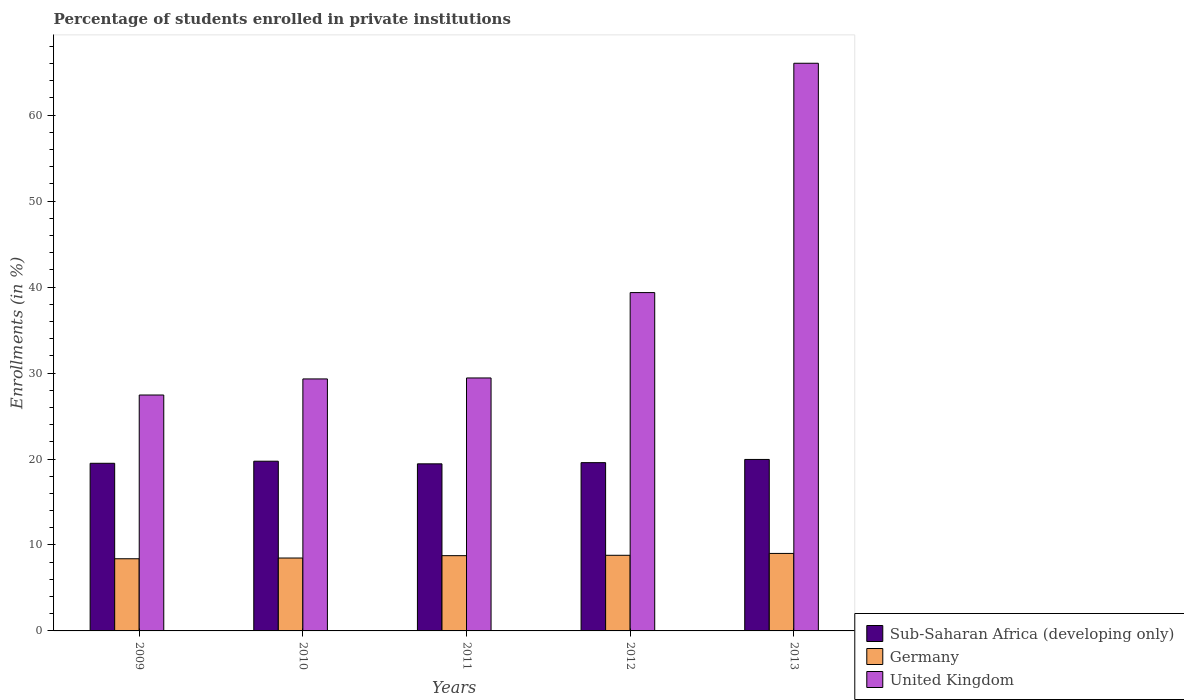Are the number of bars per tick equal to the number of legend labels?
Offer a very short reply. Yes. What is the label of the 5th group of bars from the left?
Provide a short and direct response. 2013. What is the percentage of trained teachers in Germany in 2009?
Offer a terse response. 8.4. Across all years, what is the maximum percentage of trained teachers in Germany?
Provide a short and direct response. 9.02. Across all years, what is the minimum percentage of trained teachers in Germany?
Give a very brief answer. 8.4. In which year was the percentage of trained teachers in United Kingdom minimum?
Offer a terse response. 2009. What is the total percentage of trained teachers in Germany in the graph?
Offer a very short reply. 43.45. What is the difference between the percentage of trained teachers in Germany in 2012 and that in 2013?
Give a very brief answer. -0.22. What is the difference between the percentage of trained teachers in Sub-Saharan Africa (developing only) in 2011 and the percentage of trained teachers in Germany in 2012?
Your response must be concise. 10.64. What is the average percentage of trained teachers in United Kingdom per year?
Your answer should be very brief. 38.32. In the year 2011, what is the difference between the percentage of trained teachers in Sub-Saharan Africa (developing only) and percentage of trained teachers in United Kingdom?
Make the answer very short. -9.99. What is the ratio of the percentage of trained teachers in Germany in 2010 to that in 2013?
Provide a succinct answer. 0.94. Is the difference between the percentage of trained teachers in Sub-Saharan Africa (developing only) in 2011 and 2013 greater than the difference between the percentage of trained teachers in United Kingdom in 2011 and 2013?
Provide a short and direct response. Yes. What is the difference between the highest and the second highest percentage of trained teachers in United Kingdom?
Your answer should be compact. 26.68. What is the difference between the highest and the lowest percentage of trained teachers in United Kingdom?
Your answer should be compact. 38.59. In how many years, is the percentage of trained teachers in Sub-Saharan Africa (developing only) greater than the average percentage of trained teachers in Sub-Saharan Africa (developing only) taken over all years?
Your answer should be very brief. 2. Is the sum of the percentage of trained teachers in United Kingdom in 2010 and 2012 greater than the maximum percentage of trained teachers in Germany across all years?
Make the answer very short. Yes. What does the 1st bar from the left in 2013 represents?
Give a very brief answer. Sub-Saharan Africa (developing only). What does the 3rd bar from the right in 2010 represents?
Keep it short and to the point. Sub-Saharan Africa (developing only). How many bars are there?
Offer a very short reply. 15. Are all the bars in the graph horizontal?
Offer a terse response. No. How many years are there in the graph?
Make the answer very short. 5. Are the values on the major ticks of Y-axis written in scientific E-notation?
Ensure brevity in your answer.  No. Does the graph contain any zero values?
Provide a succinct answer. No. Does the graph contain grids?
Your answer should be very brief. No. Where does the legend appear in the graph?
Keep it short and to the point. Bottom right. How many legend labels are there?
Make the answer very short. 3. What is the title of the graph?
Provide a short and direct response. Percentage of students enrolled in private institutions. Does "Korea (Republic)" appear as one of the legend labels in the graph?
Your response must be concise. No. What is the label or title of the Y-axis?
Provide a short and direct response. Enrollments (in %). What is the Enrollments (in %) in Sub-Saharan Africa (developing only) in 2009?
Your response must be concise. 19.5. What is the Enrollments (in %) of Germany in 2009?
Ensure brevity in your answer.  8.4. What is the Enrollments (in %) of United Kingdom in 2009?
Your response must be concise. 27.44. What is the Enrollments (in %) in Sub-Saharan Africa (developing only) in 2010?
Your response must be concise. 19.74. What is the Enrollments (in %) of Germany in 2010?
Your response must be concise. 8.48. What is the Enrollments (in %) of United Kingdom in 2010?
Make the answer very short. 29.32. What is the Enrollments (in %) in Sub-Saharan Africa (developing only) in 2011?
Give a very brief answer. 19.44. What is the Enrollments (in %) of Germany in 2011?
Keep it short and to the point. 8.76. What is the Enrollments (in %) of United Kingdom in 2011?
Make the answer very short. 29.43. What is the Enrollments (in %) of Sub-Saharan Africa (developing only) in 2012?
Your answer should be very brief. 19.58. What is the Enrollments (in %) in Germany in 2012?
Ensure brevity in your answer.  8.8. What is the Enrollments (in %) in United Kingdom in 2012?
Your response must be concise. 39.36. What is the Enrollments (in %) of Sub-Saharan Africa (developing only) in 2013?
Keep it short and to the point. 19.95. What is the Enrollments (in %) in Germany in 2013?
Provide a succinct answer. 9.02. What is the Enrollments (in %) in United Kingdom in 2013?
Your answer should be compact. 66.04. Across all years, what is the maximum Enrollments (in %) of Sub-Saharan Africa (developing only)?
Offer a very short reply. 19.95. Across all years, what is the maximum Enrollments (in %) of Germany?
Your response must be concise. 9.02. Across all years, what is the maximum Enrollments (in %) of United Kingdom?
Make the answer very short. 66.04. Across all years, what is the minimum Enrollments (in %) of Sub-Saharan Africa (developing only)?
Provide a succinct answer. 19.44. Across all years, what is the minimum Enrollments (in %) of Germany?
Your answer should be compact. 8.4. Across all years, what is the minimum Enrollments (in %) of United Kingdom?
Your answer should be compact. 27.44. What is the total Enrollments (in %) of Sub-Saharan Africa (developing only) in the graph?
Make the answer very short. 98.21. What is the total Enrollments (in %) of Germany in the graph?
Make the answer very short. 43.45. What is the total Enrollments (in %) of United Kingdom in the graph?
Make the answer very short. 191.59. What is the difference between the Enrollments (in %) of Sub-Saharan Africa (developing only) in 2009 and that in 2010?
Ensure brevity in your answer.  -0.24. What is the difference between the Enrollments (in %) of Germany in 2009 and that in 2010?
Make the answer very short. -0.08. What is the difference between the Enrollments (in %) in United Kingdom in 2009 and that in 2010?
Offer a very short reply. -1.87. What is the difference between the Enrollments (in %) of Sub-Saharan Africa (developing only) in 2009 and that in 2011?
Provide a short and direct response. 0.06. What is the difference between the Enrollments (in %) of Germany in 2009 and that in 2011?
Ensure brevity in your answer.  -0.36. What is the difference between the Enrollments (in %) of United Kingdom in 2009 and that in 2011?
Give a very brief answer. -1.98. What is the difference between the Enrollments (in %) of Sub-Saharan Africa (developing only) in 2009 and that in 2012?
Make the answer very short. -0.08. What is the difference between the Enrollments (in %) of Germany in 2009 and that in 2012?
Provide a succinct answer. -0.4. What is the difference between the Enrollments (in %) in United Kingdom in 2009 and that in 2012?
Your answer should be compact. -11.92. What is the difference between the Enrollments (in %) of Sub-Saharan Africa (developing only) in 2009 and that in 2013?
Your answer should be very brief. -0.45. What is the difference between the Enrollments (in %) of Germany in 2009 and that in 2013?
Give a very brief answer. -0.62. What is the difference between the Enrollments (in %) in United Kingdom in 2009 and that in 2013?
Ensure brevity in your answer.  -38.59. What is the difference between the Enrollments (in %) of Sub-Saharan Africa (developing only) in 2010 and that in 2011?
Ensure brevity in your answer.  0.31. What is the difference between the Enrollments (in %) in Germany in 2010 and that in 2011?
Make the answer very short. -0.28. What is the difference between the Enrollments (in %) in United Kingdom in 2010 and that in 2011?
Your answer should be very brief. -0.11. What is the difference between the Enrollments (in %) of Sub-Saharan Africa (developing only) in 2010 and that in 2012?
Offer a very short reply. 0.17. What is the difference between the Enrollments (in %) in Germany in 2010 and that in 2012?
Make the answer very short. -0.32. What is the difference between the Enrollments (in %) in United Kingdom in 2010 and that in 2012?
Your answer should be compact. -10.04. What is the difference between the Enrollments (in %) in Sub-Saharan Africa (developing only) in 2010 and that in 2013?
Your answer should be compact. -0.21. What is the difference between the Enrollments (in %) of Germany in 2010 and that in 2013?
Your answer should be compact. -0.54. What is the difference between the Enrollments (in %) of United Kingdom in 2010 and that in 2013?
Keep it short and to the point. -36.72. What is the difference between the Enrollments (in %) of Sub-Saharan Africa (developing only) in 2011 and that in 2012?
Your answer should be very brief. -0.14. What is the difference between the Enrollments (in %) in Germany in 2011 and that in 2012?
Keep it short and to the point. -0.04. What is the difference between the Enrollments (in %) of United Kingdom in 2011 and that in 2012?
Your response must be concise. -9.93. What is the difference between the Enrollments (in %) of Sub-Saharan Africa (developing only) in 2011 and that in 2013?
Give a very brief answer. -0.51. What is the difference between the Enrollments (in %) of Germany in 2011 and that in 2013?
Offer a very short reply. -0.26. What is the difference between the Enrollments (in %) in United Kingdom in 2011 and that in 2013?
Provide a short and direct response. -36.61. What is the difference between the Enrollments (in %) of Sub-Saharan Africa (developing only) in 2012 and that in 2013?
Give a very brief answer. -0.37. What is the difference between the Enrollments (in %) in Germany in 2012 and that in 2013?
Your answer should be compact. -0.22. What is the difference between the Enrollments (in %) in United Kingdom in 2012 and that in 2013?
Offer a very short reply. -26.68. What is the difference between the Enrollments (in %) in Sub-Saharan Africa (developing only) in 2009 and the Enrollments (in %) in Germany in 2010?
Provide a short and direct response. 11.02. What is the difference between the Enrollments (in %) of Sub-Saharan Africa (developing only) in 2009 and the Enrollments (in %) of United Kingdom in 2010?
Give a very brief answer. -9.82. What is the difference between the Enrollments (in %) of Germany in 2009 and the Enrollments (in %) of United Kingdom in 2010?
Keep it short and to the point. -20.92. What is the difference between the Enrollments (in %) in Sub-Saharan Africa (developing only) in 2009 and the Enrollments (in %) in Germany in 2011?
Keep it short and to the point. 10.75. What is the difference between the Enrollments (in %) of Sub-Saharan Africa (developing only) in 2009 and the Enrollments (in %) of United Kingdom in 2011?
Offer a terse response. -9.93. What is the difference between the Enrollments (in %) of Germany in 2009 and the Enrollments (in %) of United Kingdom in 2011?
Your response must be concise. -21.03. What is the difference between the Enrollments (in %) in Sub-Saharan Africa (developing only) in 2009 and the Enrollments (in %) in Germany in 2012?
Provide a short and direct response. 10.7. What is the difference between the Enrollments (in %) of Sub-Saharan Africa (developing only) in 2009 and the Enrollments (in %) of United Kingdom in 2012?
Ensure brevity in your answer.  -19.86. What is the difference between the Enrollments (in %) of Germany in 2009 and the Enrollments (in %) of United Kingdom in 2012?
Provide a short and direct response. -30.96. What is the difference between the Enrollments (in %) in Sub-Saharan Africa (developing only) in 2009 and the Enrollments (in %) in Germany in 2013?
Keep it short and to the point. 10.49. What is the difference between the Enrollments (in %) of Sub-Saharan Africa (developing only) in 2009 and the Enrollments (in %) of United Kingdom in 2013?
Give a very brief answer. -46.54. What is the difference between the Enrollments (in %) of Germany in 2009 and the Enrollments (in %) of United Kingdom in 2013?
Provide a succinct answer. -57.64. What is the difference between the Enrollments (in %) of Sub-Saharan Africa (developing only) in 2010 and the Enrollments (in %) of Germany in 2011?
Provide a succinct answer. 10.99. What is the difference between the Enrollments (in %) in Sub-Saharan Africa (developing only) in 2010 and the Enrollments (in %) in United Kingdom in 2011?
Offer a terse response. -9.68. What is the difference between the Enrollments (in %) of Germany in 2010 and the Enrollments (in %) of United Kingdom in 2011?
Offer a terse response. -20.95. What is the difference between the Enrollments (in %) of Sub-Saharan Africa (developing only) in 2010 and the Enrollments (in %) of Germany in 2012?
Your answer should be compact. 10.95. What is the difference between the Enrollments (in %) in Sub-Saharan Africa (developing only) in 2010 and the Enrollments (in %) in United Kingdom in 2012?
Your response must be concise. -19.62. What is the difference between the Enrollments (in %) of Germany in 2010 and the Enrollments (in %) of United Kingdom in 2012?
Provide a succinct answer. -30.88. What is the difference between the Enrollments (in %) in Sub-Saharan Africa (developing only) in 2010 and the Enrollments (in %) in Germany in 2013?
Ensure brevity in your answer.  10.73. What is the difference between the Enrollments (in %) of Sub-Saharan Africa (developing only) in 2010 and the Enrollments (in %) of United Kingdom in 2013?
Your answer should be compact. -46.3. What is the difference between the Enrollments (in %) in Germany in 2010 and the Enrollments (in %) in United Kingdom in 2013?
Provide a short and direct response. -57.56. What is the difference between the Enrollments (in %) of Sub-Saharan Africa (developing only) in 2011 and the Enrollments (in %) of Germany in 2012?
Give a very brief answer. 10.64. What is the difference between the Enrollments (in %) in Sub-Saharan Africa (developing only) in 2011 and the Enrollments (in %) in United Kingdom in 2012?
Give a very brief answer. -19.92. What is the difference between the Enrollments (in %) of Germany in 2011 and the Enrollments (in %) of United Kingdom in 2012?
Offer a terse response. -30.6. What is the difference between the Enrollments (in %) of Sub-Saharan Africa (developing only) in 2011 and the Enrollments (in %) of Germany in 2013?
Your response must be concise. 10.42. What is the difference between the Enrollments (in %) of Sub-Saharan Africa (developing only) in 2011 and the Enrollments (in %) of United Kingdom in 2013?
Provide a succinct answer. -46.6. What is the difference between the Enrollments (in %) of Germany in 2011 and the Enrollments (in %) of United Kingdom in 2013?
Your response must be concise. -57.28. What is the difference between the Enrollments (in %) of Sub-Saharan Africa (developing only) in 2012 and the Enrollments (in %) of Germany in 2013?
Offer a terse response. 10.56. What is the difference between the Enrollments (in %) in Sub-Saharan Africa (developing only) in 2012 and the Enrollments (in %) in United Kingdom in 2013?
Keep it short and to the point. -46.46. What is the difference between the Enrollments (in %) in Germany in 2012 and the Enrollments (in %) in United Kingdom in 2013?
Make the answer very short. -57.24. What is the average Enrollments (in %) in Sub-Saharan Africa (developing only) per year?
Provide a succinct answer. 19.64. What is the average Enrollments (in %) in Germany per year?
Provide a short and direct response. 8.69. What is the average Enrollments (in %) of United Kingdom per year?
Your response must be concise. 38.32. In the year 2009, what is the difference between the Enrollments (in %) of Sub-Saharan Africa (developing only) and Enrollments (in %) of Germany?
Make the answer very short. 11.11. In the year 2009, what is the difference between the Enrollments (in %) in Sub-Saharan Africa (developing only) and Enrollments (in %) in United Kingdom?
Your response must be concise. -7.94. In the year 2009, what is the difference between the Enrollments (in %) of Germany and Enrollments (in %) of United Kingdom?
Offer a very short reply. -19.05. In the year 2010, what is the difference between the Enrollments (in %) in Sub-Saharan Africa (developing only) and Enrollments (in %) in Germany?
Your answer should be compact. 11.26. In the year 2010, what is the difference between the Enrollments (in %) in Sub-Saharan Africa (developing only) and Enrollments (in %) in United Kingdom?
Ensure brevity in your answer.  -9.57. In the year 2010, what is the difference between the Enrollments (in %) of Germany and Enrollments (in %) of United Kingdom?
Your answer should be very brief. -20.84. In the year 2011, what is the difference between the Enrollments (in %) in Sub-Saharan Africa (developing only) and Enrollments (in %) in Germany?
Offer a terse response. 10.68. In the year 2011, what is the difference between the Enrollments (in %) of Sub-Saharan Africa (developing only) and Enrollments (in %) of United Kingdom?
Ensure brevity in your answer.  -9.99. In the year 2011, what is the difference between the Enrollments (in %) of Germany and Enrollments (in %) of United Kingdom?
Keep it short and to the point. -20.67. In the year 2012, what is the difference between the Enrollments (in %) in Sub-Saharan Africa (developing only) and Enrollments (in %) in Germany?
Offer a terse response. 10.78. In the year 2012, what is the difference between the Enrollments (in %) of Sub-Saharan Africa (developing only) and Enrollments (in %) of United Kingdom?
Your response must be concise. -19.78. In the year 2012, what is the difference between the Enrollments (in %) of Germany and Enrollments (in %) of United Kingdom?
Provide a succinct answer. -30.56. In the year 2013, what is the difference between the Enrollments (in %) of Sub-Saharan Africa (developing only) and Enrollments (in %) of Germany?
Keep it short and to the point. 10.93. In the year 2013, what is the difference between the Enrollments (in %) in Sub-Saharan Africa (developing only) and Enrollments (in %) in United Kingdom?
Ensure brevity in your answer.  -46.09. In the year 2013, what is the difference between the Enrollments (in %) of Germany and Enrollments (in %) of United Kingdom?
Your answer should be compact. -57.02. What is the ratio of the Enrollments (in %) in Germany in 2009 to that in 2010?
Keep it short and to the point. 0.99. What is the ratio of the Enrollments (in %) in United Kingdom in 2009 to that in 2010?
Keep it short and to the point. 0.94. What is the ratio of the Enrollments (in %) of Germany in 2009 to that in 2011?
Your response must be concise. 0.96. What is the ratio of the Enrollments (in %) of United Kingdom in 2009 to that in 2011?
Your answer should be compact. 0.93. What is the ratio of the Enrollments (in %) in Germany in 2009 to that in 2012?
Give a very brief answer. 0.95. What is the ratio of the Enrollments (in %) in United Kingdom in 2009 to that in 2012?
Offer a terse response. 0.7. What is the ratio of the Enrollments (in %) of Sub-Saharan Africa (developing only) in 2009 to that in 2013?
Your answer should be very brief. 0.98. What is the ratio of the Enrollments (in %) in Germany in 2009 to that in 2013?
Keep it short and to the point. 0.93. What is the ratio of the Enrollments (in %) of United Kingdom in 2009 to that in 2013?
Your response must be concise. 0.42. What is the ratio of the Enrollments (in %) in Sub-Saharan Africa (developing only) in 2010 to that in 2011?
Provide a succinct answer. 1.02. What is the ratio of the Enrollments (in %) of Germany in 2010 to that in 2011?
Offer a terse response. 0.97. What is the ratio of the Enrollments (in %) of United Kingdom in 2010 to that in 2011?
Give a very brief answer. 1. What is the ratio of the Enrollments (in %) of Sub-Saharan Africa (developing only) in 2010 to that in 2012?
Make the answer very short. 1.01. What is the ratio of the Enrollments (in %) in Germany in 2010 to that in 2012?
Give a very brief answer. 0.96. What is the ratio of the Enrollments (in %) of United Kingdom in 2010 to that in 2012?
Offer a terse response. 0.74. What is the ratio of the Enrollments (in %) in Germany in 2010 to that in 2013?
Your answer should be compact. 0.94. What is the ratio of the Enrollments (in %) of United Kingdom in 2010 to that in 2013?
Provide a succinct answer. 0.44. What is the ratio of the Enrollments (in %) in Sub-Saharan Africa (developing only) in 2011 to that in 2012?
Offer a very short reply. 0.99. What is the ratio of the Enrollments (in %) in Germany in 2011 to that in 2012?
Ensure brevity in your answer.  1. What is the ratio of the Enrollments (in %) in United Kingdom in 2011 to that in 2012?
Make the answer very short. 0.75. What is the ratio of the Enrollments (in %) of Sub-Saharan Africa (developing only) in 2011 to that in 2013?
Give a very brief answer. 0.97. What is the ratio of the Enrollments (in %) in Germany in 2011 to that in 2013?
Your answer should be very brief. 0.97. What is the ratio of the Enrollments (in %) in United Kingdom in 2011 to that in 2013?
Ensure brevity in your answer.  0.45. What is the ratio of the Enrollments (in %) in Sub-Saharan Africa (developing only) in 2012 to that in 2013?
Offer a very short reply. 0.98. What is the ratio of the Enrollments (in %) of Germany in 2012 to that in 2013?
Your answer should be compact. 0.98. What is the ratio of the Enrollments (in %) of United Kingdom in 2012 to that in 2013?
Your response must be concise. 0.6. What is the difference between the highest and the second highest Enrollments (in %) in Sub-Saharan Africa (developing only)?
Give a very brief answer. 0.21. What is the difference between the highest and the second highest Enrollments (in %) in Germany?
Your answer should be compact. 0.22. What is the difference between the highest and the second highest Enrollments (in %) of United Kingdom?
Make the answer very short. 26.68. What is the difference between the highest and the lowest Enrollments (in %) of Sub-Saharan Africa (developing only)?
Offer a very short reply. 0.51. What is the difference between the highest and the lowest Enrollments (in %) in Germany?
Your answer should be very brief. 0.62. What is the difference between the highest and the lowest Enrollments (in %) of United Kingdom?
Make the answer very short. 38.59. 